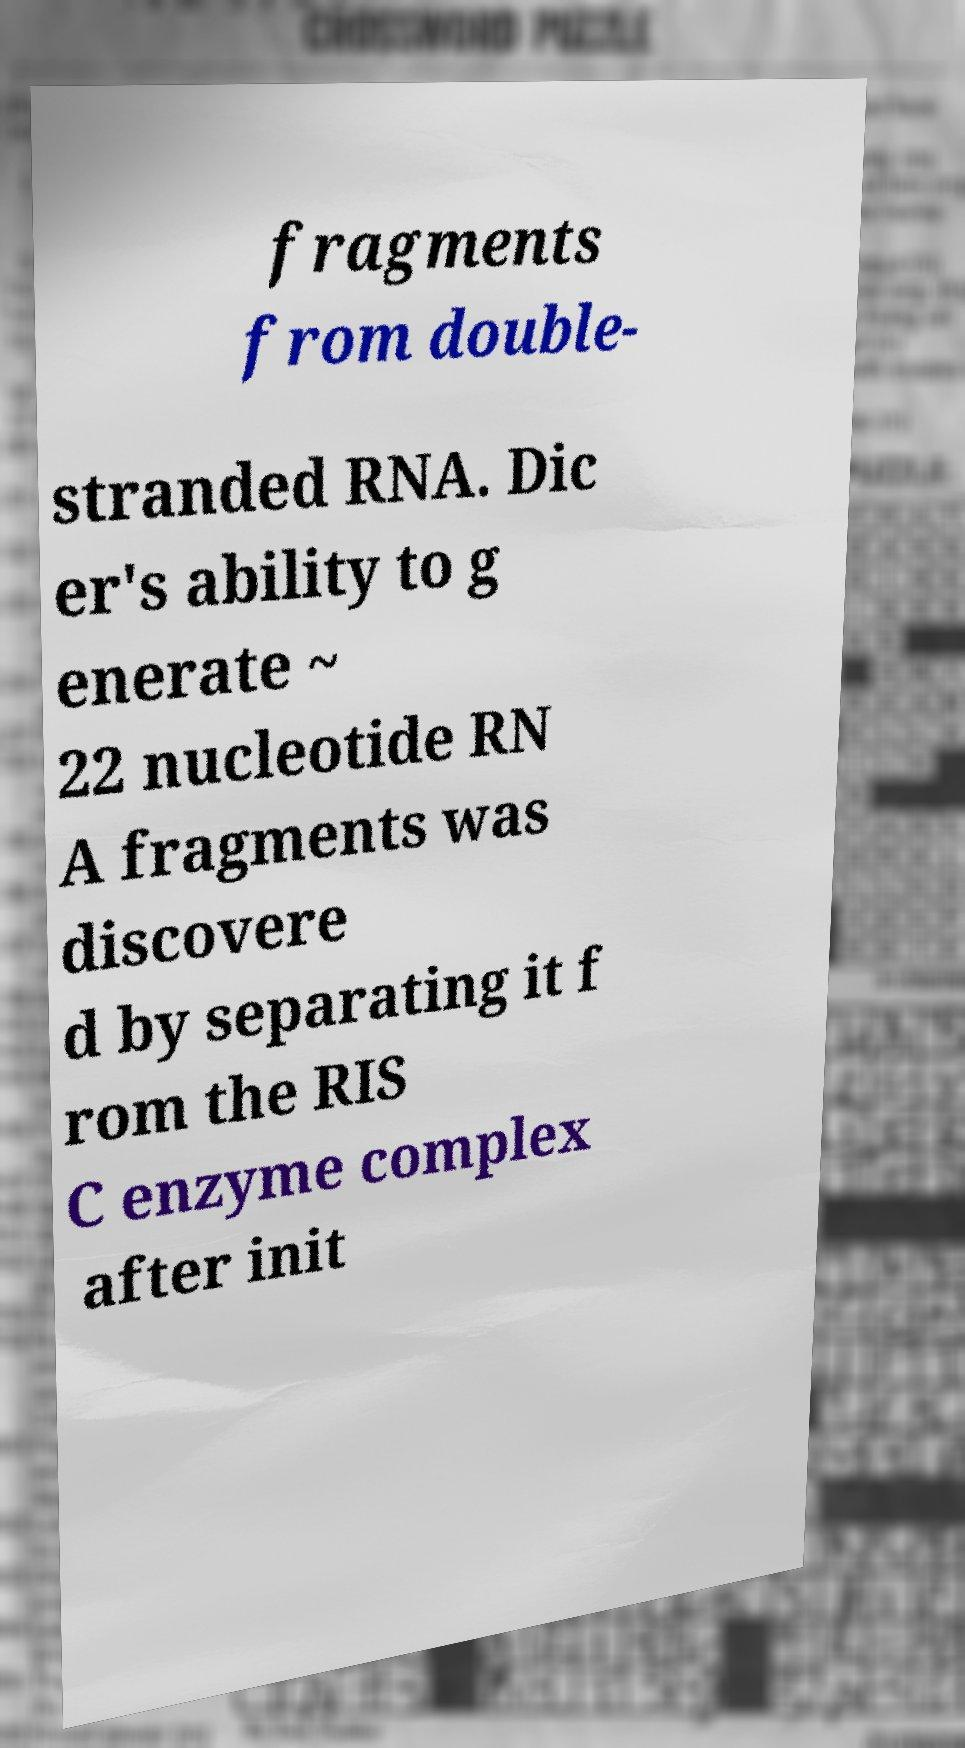Please read and relay the text visible in this image. What does it say? fragments from double- stranded RNA. Dic er's ability to g enerate ~ 22 nucleotide RN A fragments was discovere d by separating it f rom the RIS C enzyme complex after init 